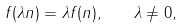<formula> <loc_0><loc_0><loc_500><loc_500>f ( \lambda n ) = \lambda f ( n ) , \quad \lambda \neq 0 ,</formula> 